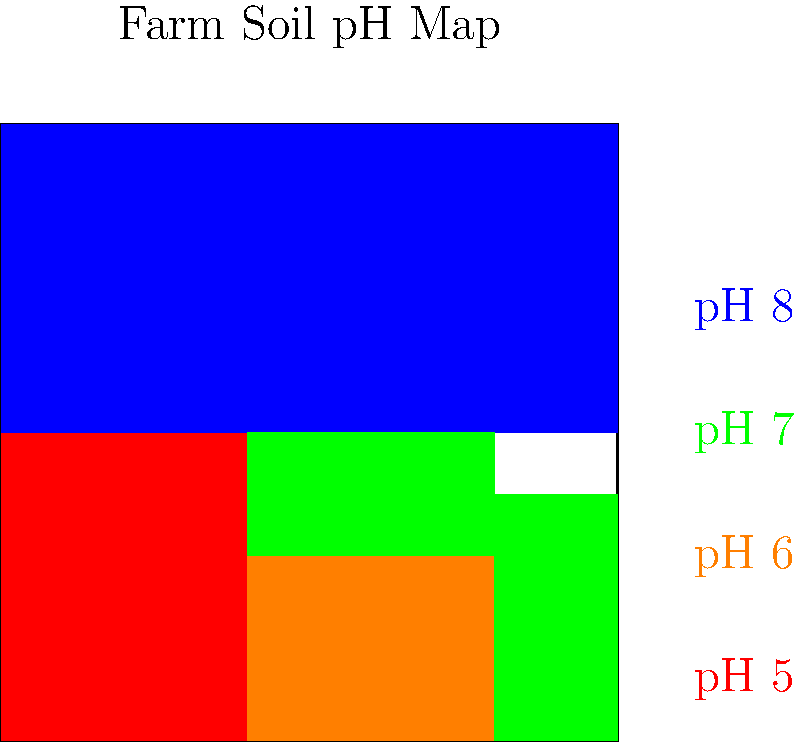Based on the color-coded soil pH map of your farm, which pH level covers the largest area, and what implications does this have for your crop rotation system and sustainable farming practices? To answer this question, we need to analyze the color-coded map and understand the implications of different soil pH levels:

1. Identify the colors and their corresponding pH levels:
   - Red: pH 5
   - Orange: pH 6
   - Green: pH 7
   - Blue: pH 8

2. Estimate the area covered by each color:
   - pH 5 (Red): Covers a small area in the bottom-left corner
   - pH 6 (Orange): Covers a moderate area in the bottom-center
   - pH 7 (Green): Covers two separate areas in the bottom-right and center
   - pH 8 (Blue): Covers the entire top half of the farm

3. Determine the largest area:
   The blue area (pH 8) covers approximately half of the farm, making it the largest.

4. Implications for crop rotation and sustainable farming:
   - pH 8 is slightly alkaline, which can affect nutrient availability.
   - Some crops prefer slightly acidic soils (pH 6-7), so the large alkaline area may limit crop choices.
   - A varied pH across the farm allows for diverse crop rotation, promoting soil health and pest control.
   - Sustainable practices to consider:
     a. Use of cover crops or green manures to gradually lower pH in alkaline areas.
     b. Implement precision agriculture techniques to apply amendments only where needed.
     c. Choose crops suited to alkaline soils for the large pH 8 area.
     d. Rotate crops between different pH zones to maximize soil health and nutrient cycling.

5. Conclusion:
   The largest area has a pH of 8, which requires careful crop selection and management practices to maintain sustainable and efficient farming operations.
Answer: pH 8; requires careful crop selection and sustainable management practices 